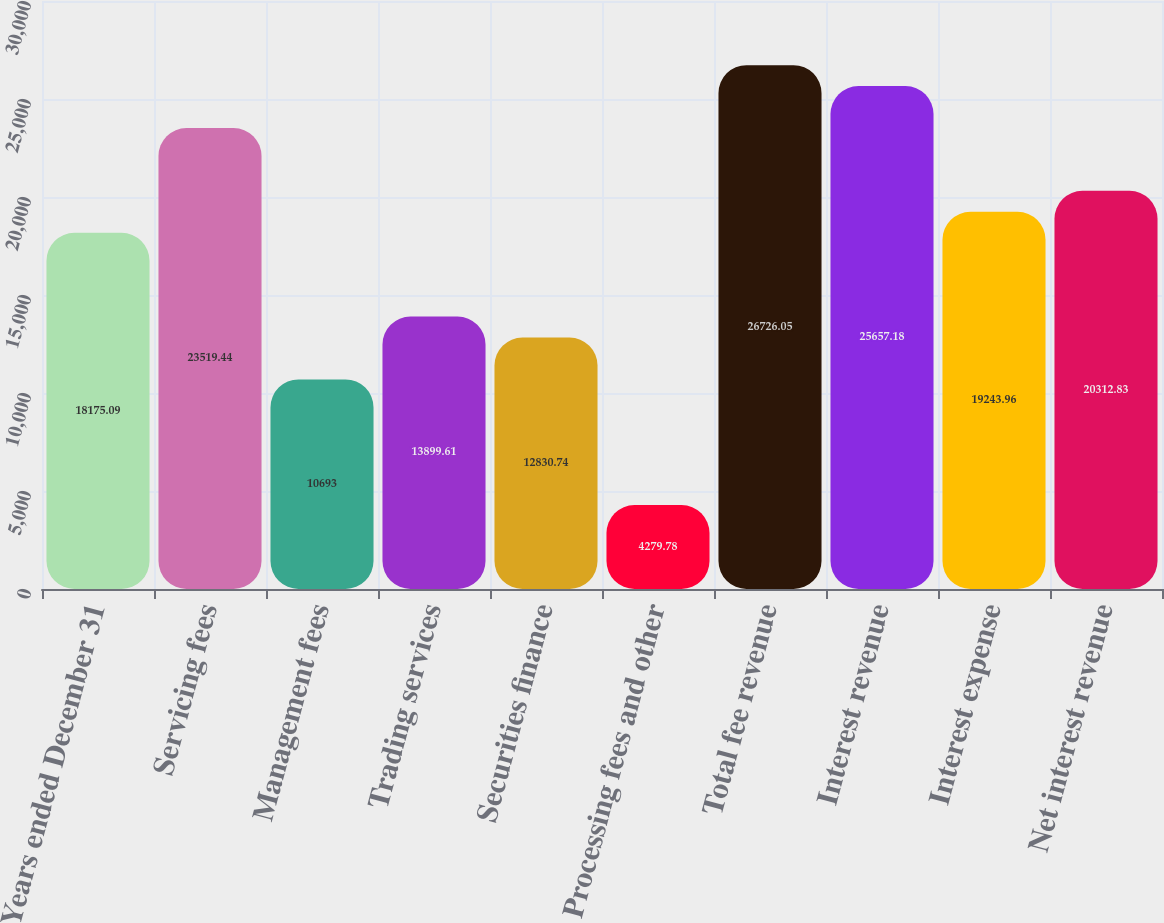Convert chart. <chart><loc_0><loc_0><loc_500><loc_500><bar_chart><fcel>Years ended December 31<fcel>Servicing fees<fcel>Management fees<fcel>Trading services<fcel>Securities finance<fcel>Processing fees and other<fcel>Total fee revenue<fcel>Interest revenue<fcel>Interest expense<fcel>Net interest revenue<nl><fcel>18175.1<fcel>23519.4<fcel>10693<fcel>13899.6<fcel>12830.7<fcel>4279.78<fcel>26726<fcel>25657.2<fcel>19244<fcel>20312.8<nl></chart> 